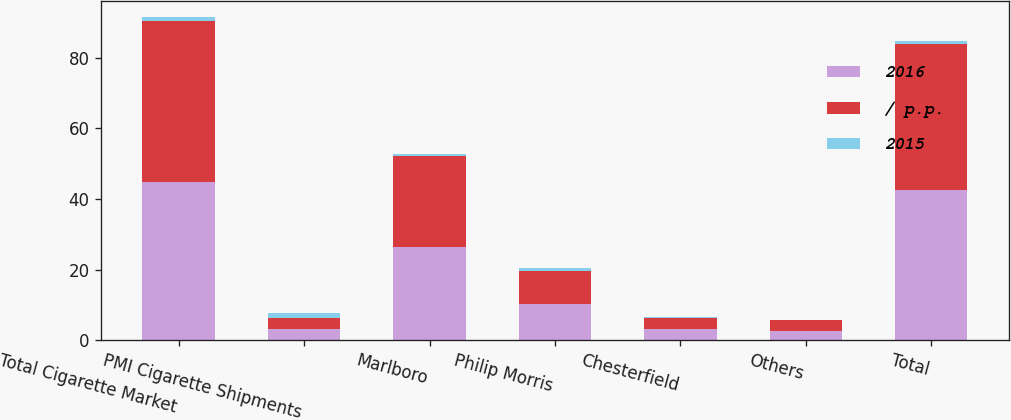<chart> <loc_0><loc_0><loc_500><loc_500><stacked_bar_chart><ecel><fcel>Total Cigarette Market<fcel>PMI Cigarette Shipments<fcel>Marlboro<fcel>Philip Morris<fcel>Chesterfield<fcel>Others<fcel>Total<nl><fcel>2016<fcel>44.9<fcel>3.1<fcel>26.4<fcel>10.2<fcel>3.1<fcel>2.7<fcel>42.4<nl><fcel>/ p.p.<fcel>45.5<fcel>3.1<fcel>25.9<fcel>9.5<fcel>3.3<fcel>2.9<fcel>41.6<nl><fcel>2015<fcel>1.2<fcel>1.6<fcel>0.5<fcel>0.7<fcel>0.2<fcel>0.2<fcel>0.8<nl></chart> 